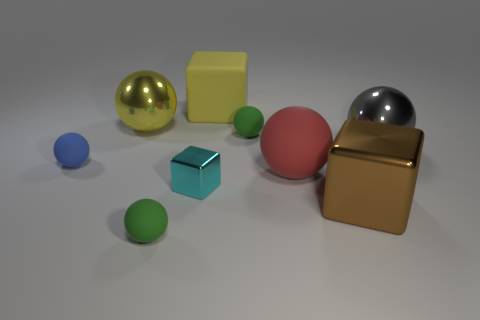Subtract all green spheres. How many spheres are left? 4 Subtract all green matte balls. How many balls are left? 4 Subtract all cyan balls. Subtract all yellow cubes. How many balls are left? 6 Add 1 small blue matte spheres. How many objects exist? 10 Subtract all balls. How many objects are left? 3 Subtract 0 blue blocks. How many objects are left? 9 Subtract all big red rubber cubes. Subtract all matte cubes. How many objects are left? 8 Add 5 large metal objects. How many large metal objects are left? 8 Add 7 large brown metal blocks. How many large brown metal blocks exist? 8 